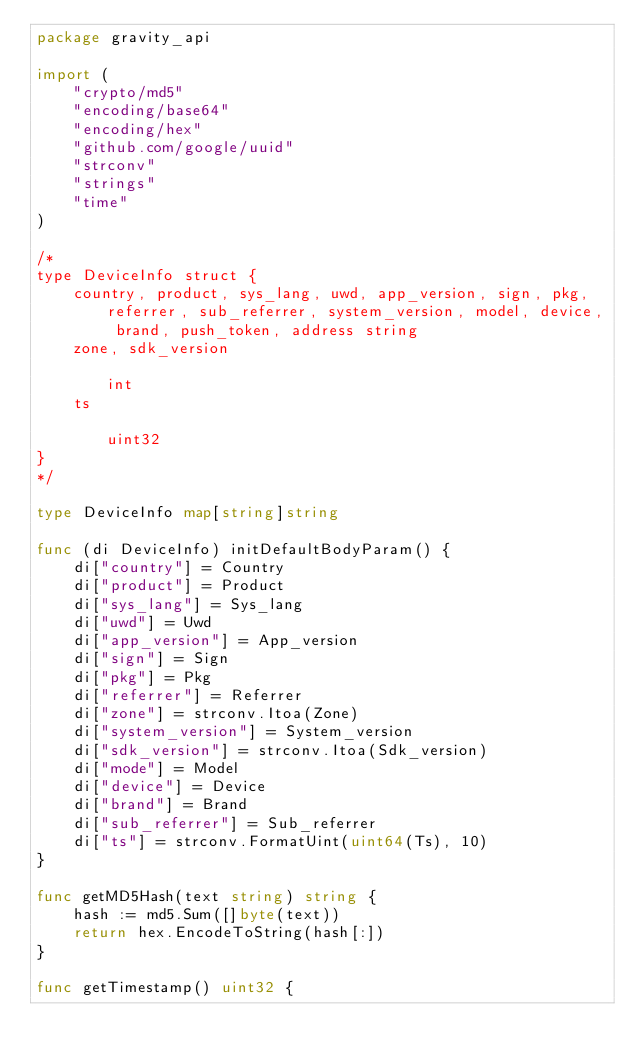<code> <loc_0><loc_0><loc_500><loc_500><_Go_>package gravity_api

import (
	"crypto/md5"
	"encoding/base64"
	"encoding/hex"
	"github.com/google/uuid"
	"strconv"
	"strings"
	"time"
)

/*
type DeviceInfo struct {
	country, product, sys_lang, uwd, app_version, sign, pkg, referrer, sub_referrer, system_version, model, device, brand, push_token, address string
	zone, sdk_version                                                                                                                          int
	ts                                                                                                                                         uint32
}
*/

type DeviceInfo map[string]string

func (di DeviceInfo) initDefaultBodyParam() {
	di["country"] = Country
	di["product"] = Product
	di["sys_lang"] = Sys_lang
	di["uwd"] = Uwd
	di["app_version"] = App_version
	di["sign"] = Sign
	di["pkg"] = Pkg
	di["referrer"] = Referrer
	di["zone"] = strconv.Itoa(Zone)
	di["system_version"] = System_version
	di["sdk_version"] = strconv.Itoa(Sdk_version)
	di["mode"] = Model
	di["device"] = Device
	di["brand"] = Brand
	di["sub_referrer"] = Sub_referrer
	di["ts"] = strconv.FormatUint(uint64(Ts), 10)
}

func getMD5Hash(text string) string {
	hash := md5.Sum([]byte(text))
	return hex.EncodeToString(hash[:])
}

func getTimestamp() uint32 {</code> 